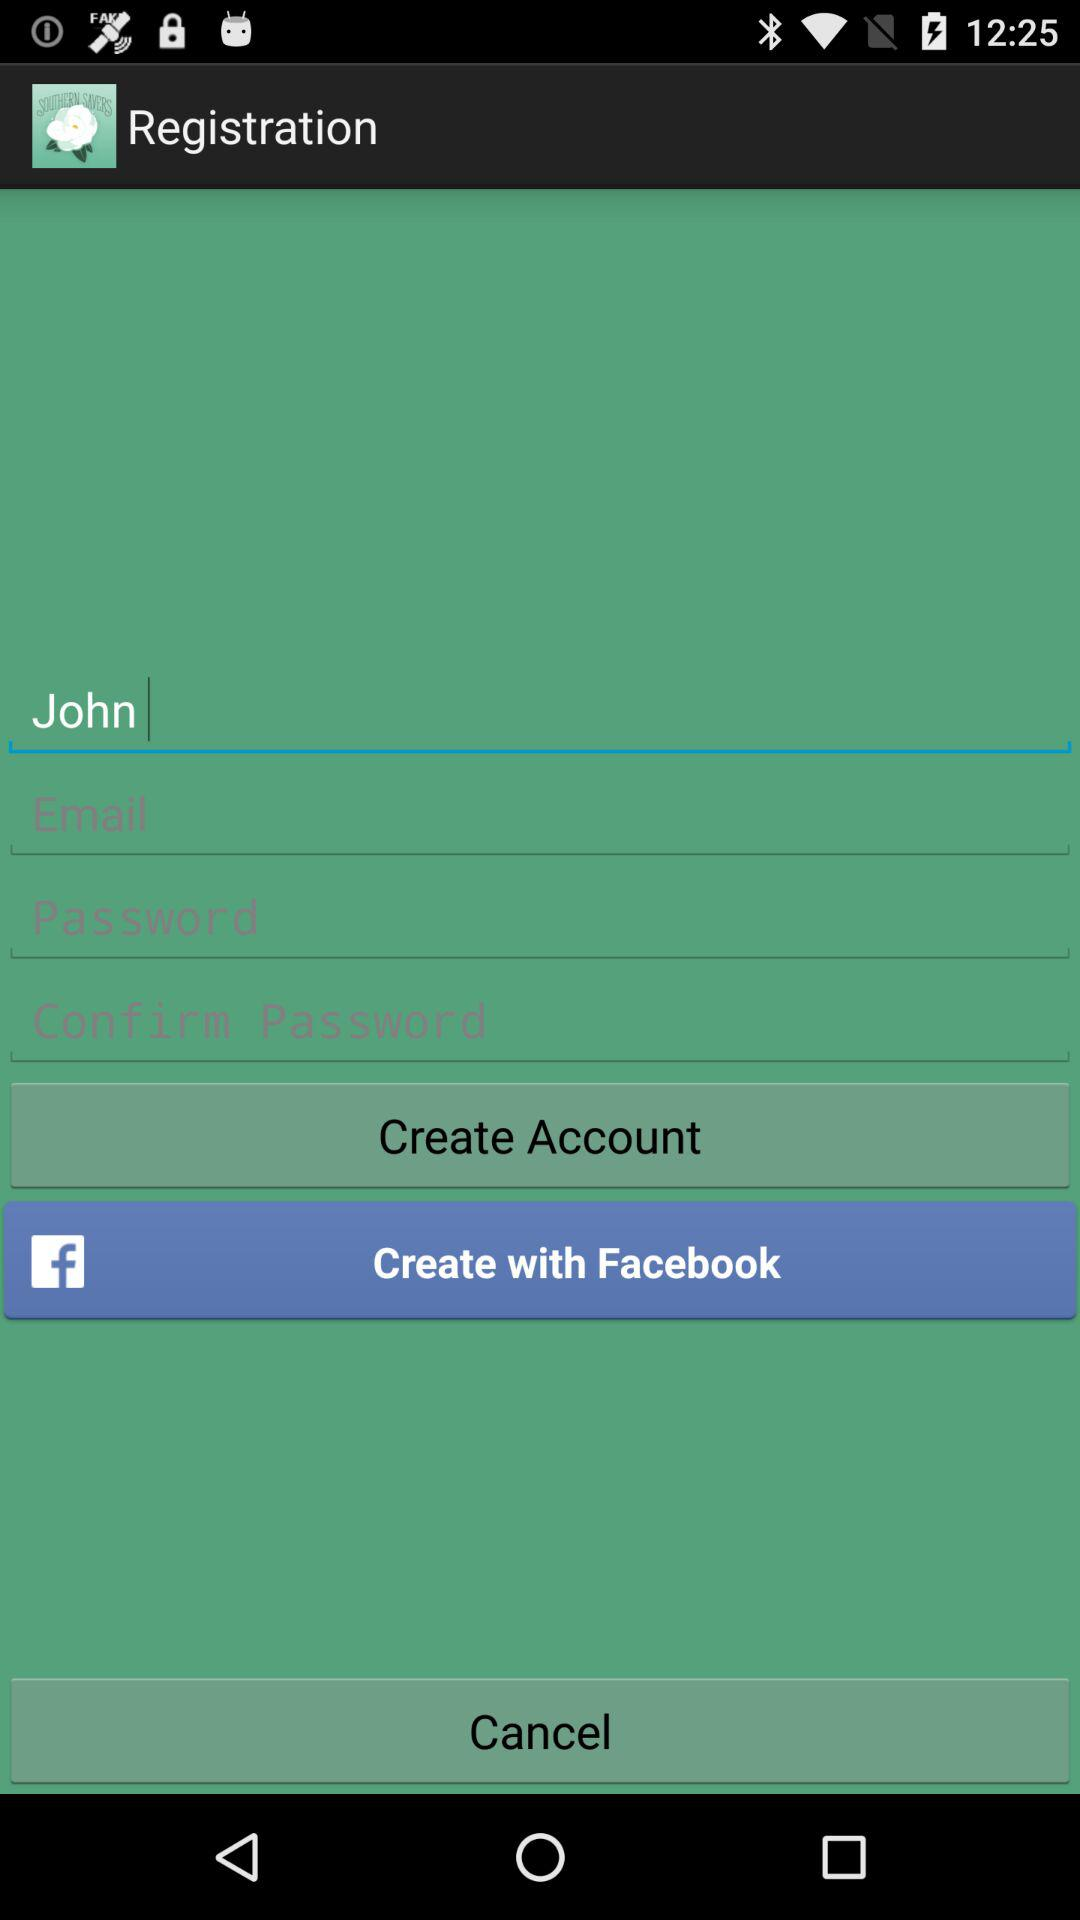What other option is given to create an account? The option is Facebook. 